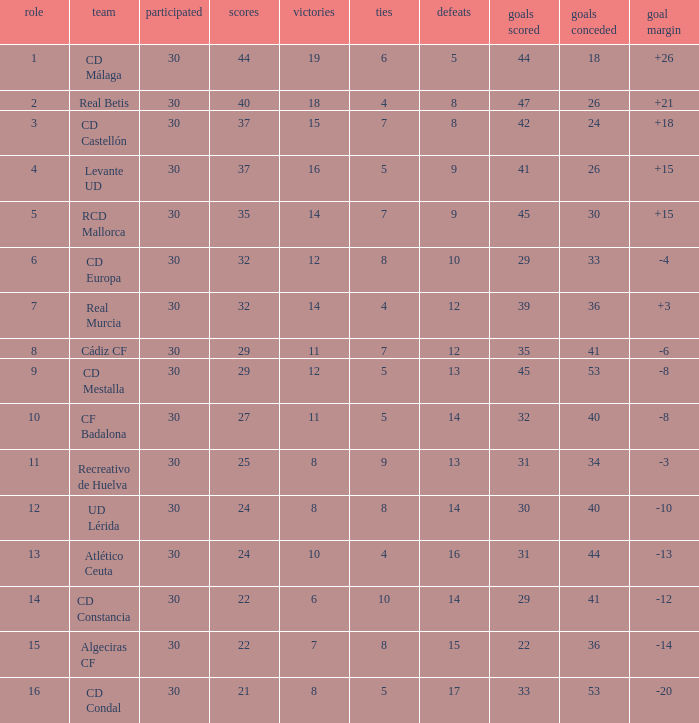What is the number of losses when the goal difference was -8, and position is smaller than 10? 1.0. 